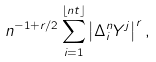Convert formula to latex. <formula><loc_0><loc_0><loc_500><loc_500>n ^ { - 1 + r / 2 } \sum _ { i = 1 } ^ { \left \lfloor n t \right \rfloor } \left | \Delta _ { i } ^ { n } Y ^ { j } \right | ^ { r } ,</formula> 